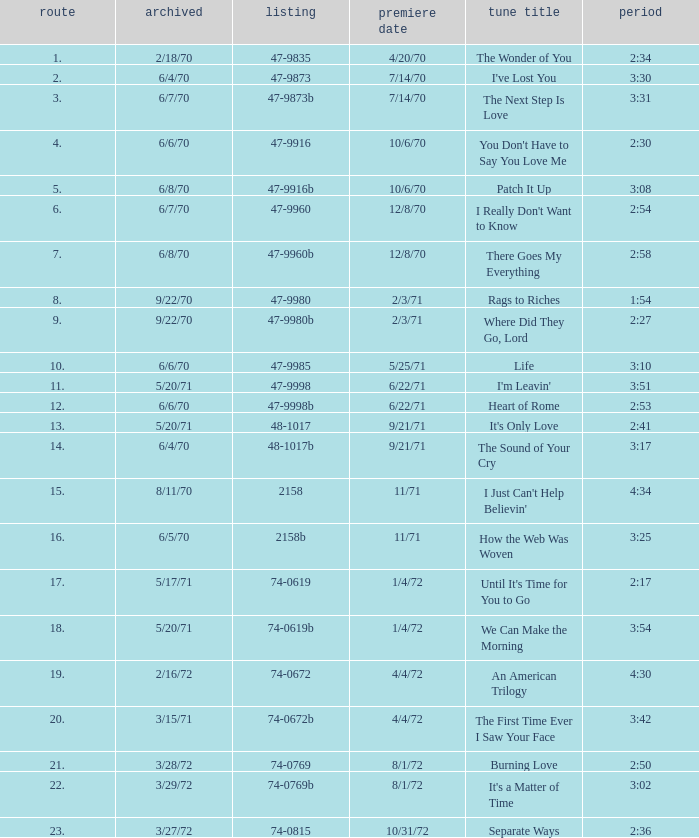Which song was released 12/8/70 with a time of 2:54? I Really Don't Want to Know. 